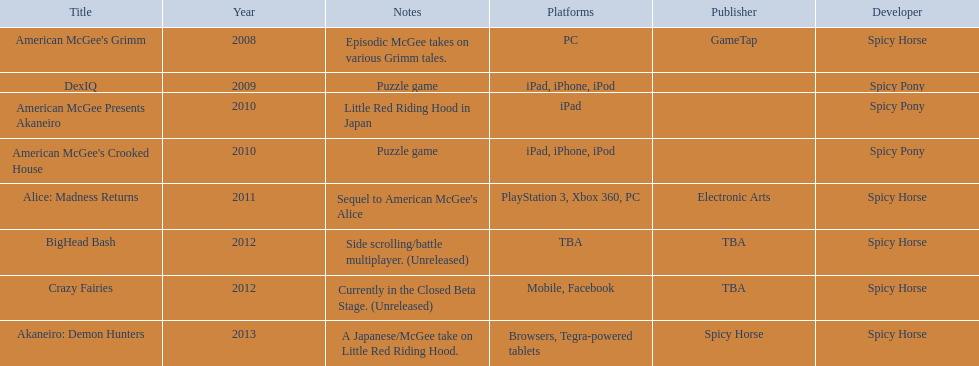How many platforms did american mcgee's grimm run on? 1. 